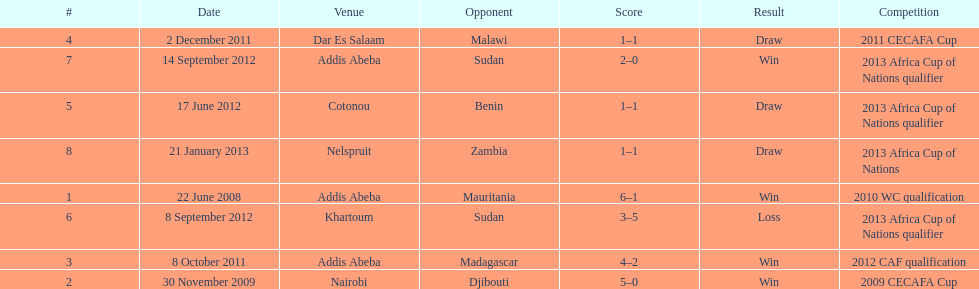What date gives was their only loss? 8 September 2012. 